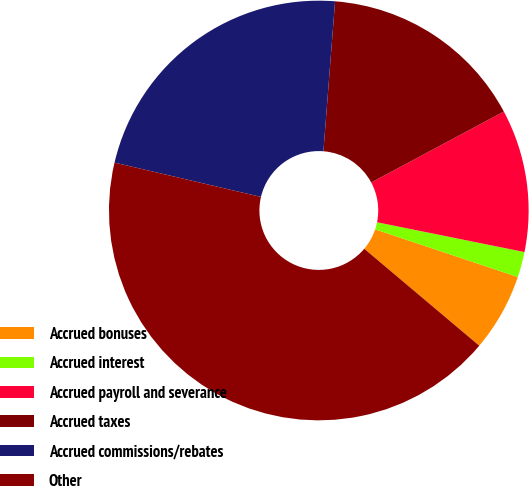Convert chart. <chart><loc_0><loc_0><loc_500><loc_500><pie_chart><fcel>Accrued bonuses<fcel>Accrued interest<fcel>Accrued payroll and severance<fcel>Accrued taxes<fcel>Accrued commissions/rebates<fcel>Other<nl><fcel>6.01%<fcel>1.96%<fcel>10.99%<fcel>15.95%<fcel>22.57%<fcel>42.52%<nl></chart> 